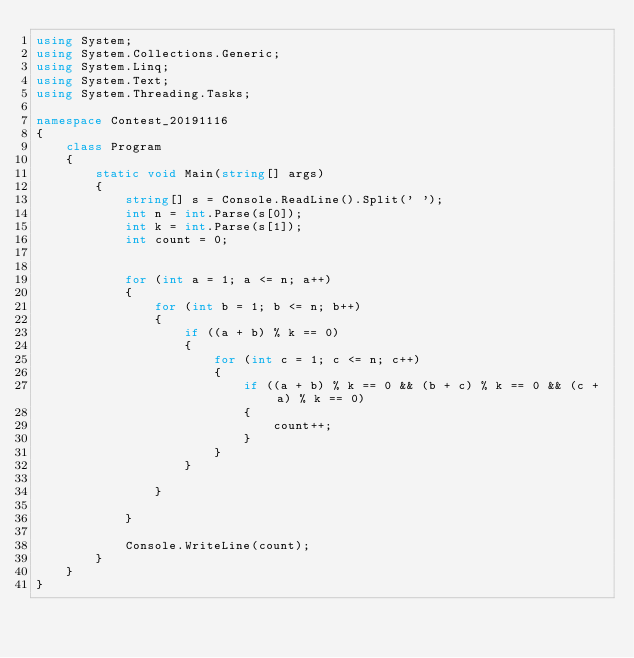Convert code to text. <code><loc_0><loc_0><loc_500><loc_500><_C#_>using System;
using System.Collections.Generic;
using System.Linq;
using System.Text;
using System.Threading.Tasks;

namespace Contest_20191116
{
    class Program
    {
        static void Main(string[] args)
        {
            string[] s = Console.ReadLine().Split(' ');
            int n = int.Parse(s[0]);
            int k = int.Parse(s[1]);
            int count = 0;
          

            for (int a = 1; a <= n; a++)
            {
                for (int b = 1; b <= n; b++)
                {
                    if ((a + b) % k == 0)
                    {
                        for (int c = 1; c <= n; c++)
                        {
                            if ((a + b) % k == 0 && (b + c) % k == 0 && (c + a) % k == 0)
                            {
                                count++;
                            }
                        }
                    }

                }

            }

            Console.WriteLine(count);
        }
    }
}
</code> 